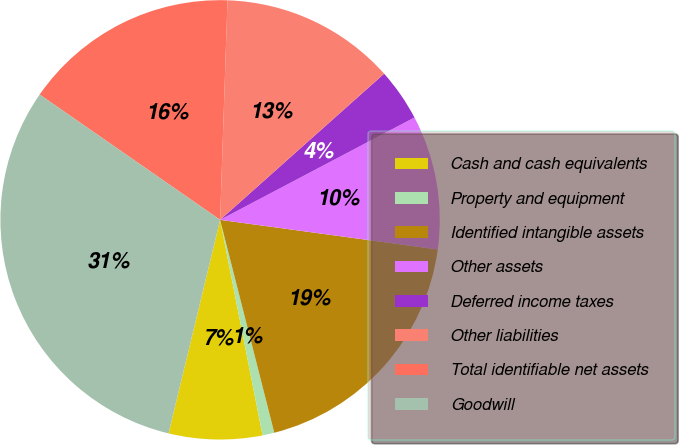Convert chart. <chart><loc_0><loc_0><loc_500><loc_500><pie_chart><fcel>Cash and cash equivalents<fcel>Property and equipment<fcel>Identified intangible assets<fcel>Other assets<fcel>Deferred income taxes<fcel>Other liabilities<fcel>Total identifiable net assets<fcel>Goodwill<nl><fcel>6.87%<fcel>0.87%<fcel>18.88%<fcel>9.87%<fcel>3.87%<fcel>12.88%<fcel>15.88%<fcel>30.89%<nl></chart> 